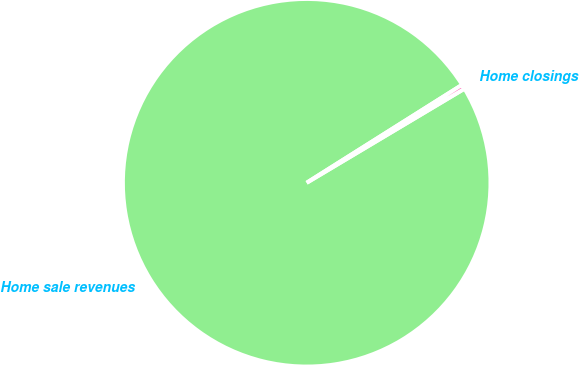Convert chart to OTSL. <chart><loc_0><loc_0><loc_500><loc_500><pie_chart><fcel>Home sale revenues<fcel>Home closings<nl><fcel>99.61%<fcel>0.39%<nl></chart> 